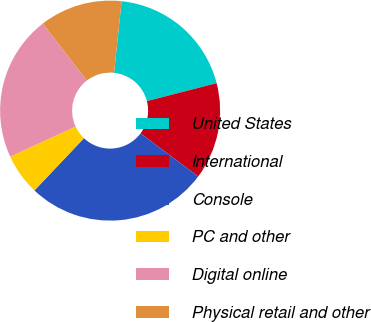Convert chart to OTSL. <chart><loc_0><loc_0><loc_500><loc_500><pie_chart><fcel>United States<fcel>International<fcel>Console<fcel>PC and other<fcel>Digital online<fcel>Physical retail and other<nl><fcel>19.32%<fcel>14.23%<fcel>26.86%<fcel>6.05%<fcel>21.4%<fcel>12.15%<nl></chart> 